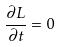<formula> <loc_0><loc_0><loc_500><loc_500>\frac { \partial L } { \partial t } = 0</formula> 